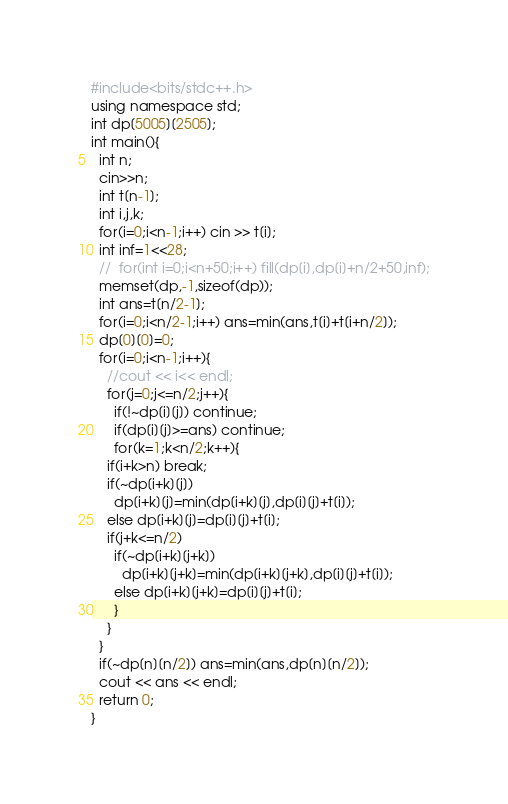<code> <loc_0><loc_0><loc_500><loc_500><_C++_>#include<bits/stdc++.h>
using namespace std;
int dp[5005][2505];
int main(){
  int n;
  cin>>n;
  int t[n-1];
  int i,j,k;
  for(i=0;i<n-1;i++) cin >> t[i];
  int inf=1<<28;
  //  for(int i=0;i<n+50;i++) fill(dp[i],dp[i]+n/2+50,inf);
  memset(dp,-1,sizeof(dp));
  int ans=t[n/2-1];
  for(i=0;i<n/2-1;i++) ans=min(ans,t[i]+t[i+n/2]);
  dp[0][0]=0;
  for(i=0;i<n-1;i++){
    //cout << i<< endl;
    for(j=0;j<=n/2;j++){
      if(!~dp[i][j]) continue;
      if(dp[i][j]>=ans) continue;
      for(k=1;k<n/2;k++){
	if(i+k>n) break;
	if(~dp[i+k][j])
	  dp[i+k][j]=min(dp[i+k][j],dp[i][j]+t[i]);
	else dp[i+k][j]=dp[i][j]+t[i];
	if(j+k<=n/2)
	  if(~dp[i+k][j+k])
	    dp[i+k][j+k]=min(dp[i+k][j+k],dp[i][j]+t[i]);
	  else dp[i+k][j+k]=dp[i][j]+t[i];
      }
    }
  }
  if(~dp[n][n/2]) ans=min(ans,dp[n][n/2]);
  cout << ans << endl;
  return 0;
}</code> 